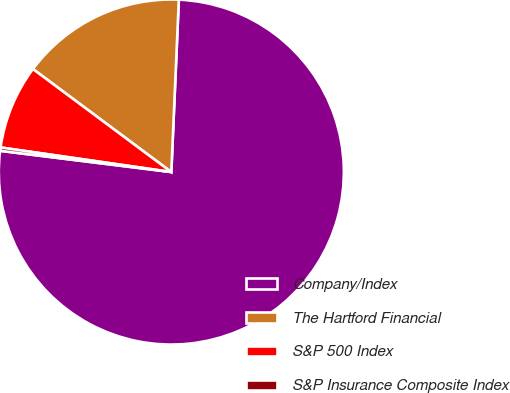Convert chart to OTSL. <chart><loc_0><loc_0><loc_500><loc_500><pie_chart><fcel>Company/Index<fcel>The Hartford Financial<fcel>S&P 500 Index<fcel>S&P Insurance Composite Index<nl><fcel>76.27%<fcel>15.51%<fcel>7.91%<fcel>0.31%<nl></chart> 